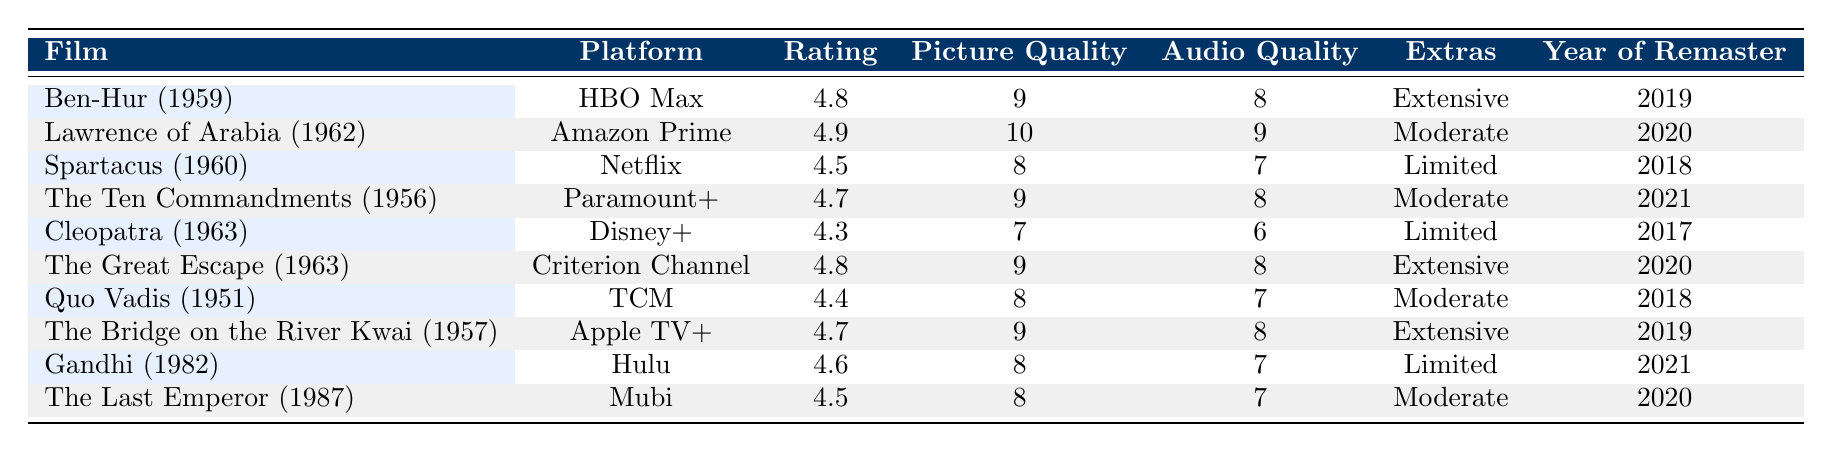What is the rating for "The Great Escape"? According to the table, the rating for "The Great Escape (1963)" listed under the platform Criterion Channel is 4.8.
Answer: 4.8 Which film has the highest picture quality rating? By examining the Picture Quality column, "Lawrence of Arabia (1962)" has the highest score of 10.
Answer: Lawrence of Arabia (1962) Is "Cleopatra" rated higher than "Gandhi"? Looking at the Ratings, "Cleopatra (1963)" has a rating of 4.3, while "Gandhi (1982)" has a rating of 4.6. Therefore, "Cleopatra" is not rated higher than "Gandhi."
Answer: No What is the average viewer rating of all films listed? To find the average, we total all the ratings: (4.8 + 4.9 + 4.5 + 4.7 + 4.3 + 4.8 + 4.4 + 4.7 + 4.6 + 4.5) = 46.5. There are 10 films, so 46.5 / 10 = 4.65.
Answer: 4.65 Which film has the most extensive extras? From the Extras column, we find that both "Ben-Hur (1959)", "The Great Escape (1963)", and "The Bridge on the River Kwai (1957)" are marked as having "Extensive" extras.
Answer: Ben-Hur (1959), The Great Escape (1963), The Bridge on the River Kwai (1957) Which platform has the lowest viewer reviews? By examining the Viewer Reviews column, "The Last Emperor (1987)" has the fewest reviews with a total of 380.
Answer: Mubi Is "Spartacus" the only film with limited extras? Looking at the Extras column, “Spartacus (1960)” is listed as having "Limited" extras, but so are "Cleopatra (1963)" and "Gandhi (1982)", which means "Spartacus" is not the only one.
Answer: No What is the total number of viewer reviews for films remastered in 2020? The films remastered in 2020 are "Lawrence of Arabia (1962)" with 980 reviews, "The Great Escape (1963)" with 710 reviews, and "The Last Emperor (1987)" with 380 reviews. Adding these gives: 980 + 710 + 380 = 2070.
Answer: 2070 